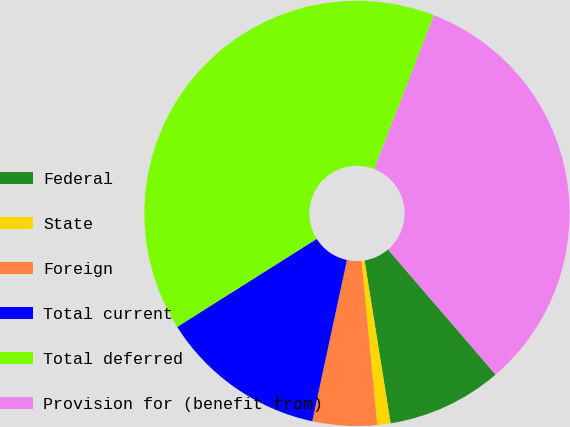<chart> <loc_0><loc_0><loc_500><loc_500><pie_chart><fcel>Federal<fcel>State<fcel>Foreign<fcel>Total current<fcel>Total deferred<fcel>Provision for (benefit from)<nl><fcel>8.78%<fcel>1.01%<fcel>4.89%<fcel>12.67%<fcel>39.87%<fcel>32.79%<nl></chart> 